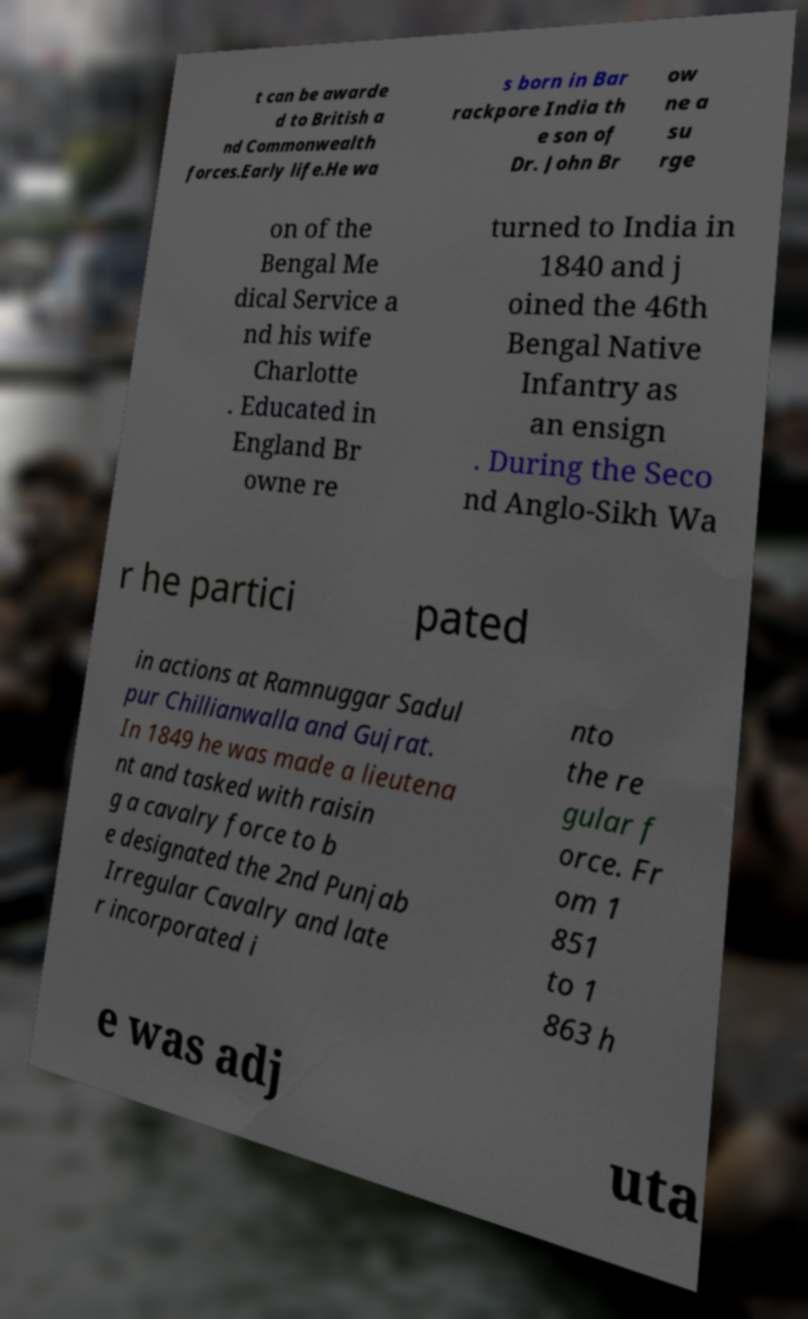Can you accurately transcribe the text from the provided image for me? t can be awarde d to British a nd Commonwealth forces.Early life.He wa s born in Bar rackpore India th e son of Dr. John Br ow ne a su rge on of the Bengal Me dical Service a nd his wife Charlotte . Educated in England Br owne re turned to India in 1840 and j oined the 46th Bengal Native Infantry as an ensign . During the Seco nd Anglo-Sikh Wa r he partici pated in actions at Ramnuggar Sadul pur Chillianwalla and Gujrat. In 1849 he was made a lieutena nt and tasked with raisin g a cavalry force to b e designated the 2nd Punjab Irregular Cavalry and late r incorporated i nto the re gular f orce. Fr om 1 851 to 1 863 h e was adj uta 